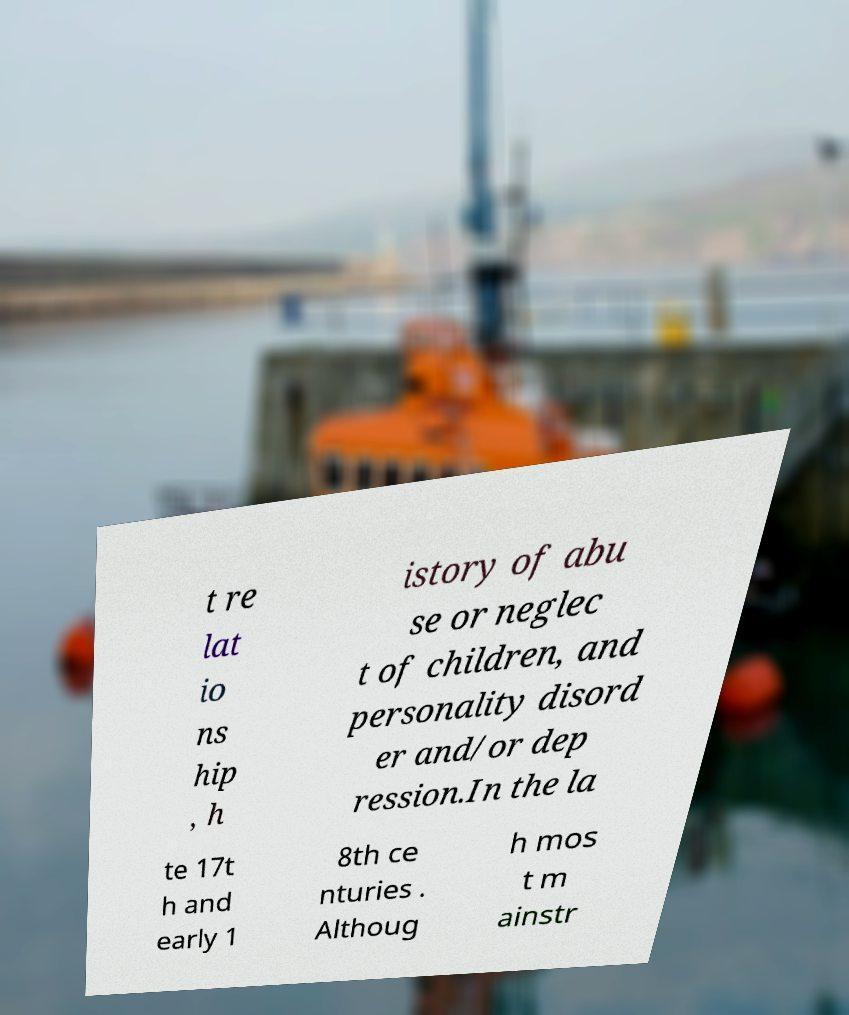For documentation purposes, I need the text within this image transcribed. Could you provide that? t re lat io ns hip , h istory of abu se or neglec t of children, and personality disord er and/or dep ression.In the la te 17t h and early 1 8th ce nturies . Althoug h mos t m ainstr 